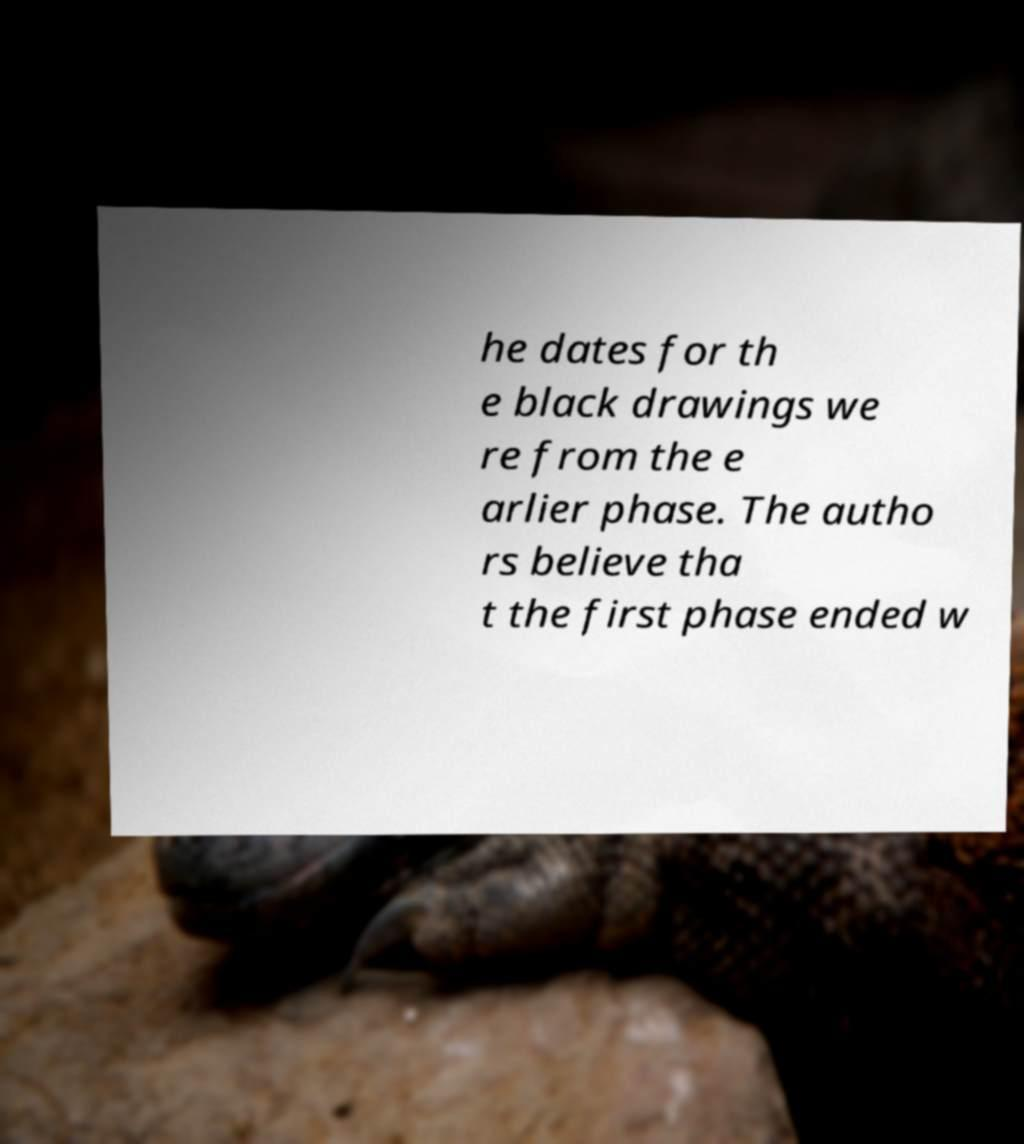There's text embedded in this image that I need extracted. Can you transcribe it verbatim? he dates for th e black drawings we re from the e arlier phase. The autho rs believe tha t the first phase ended w 